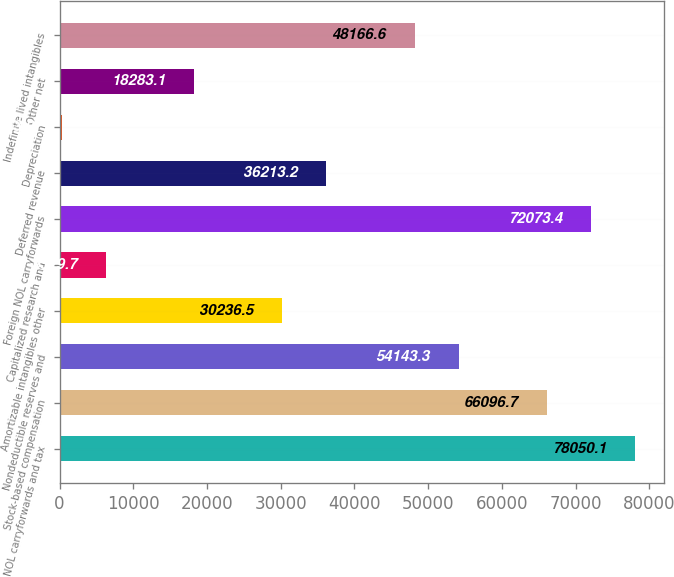<chart> <loc_0><loc_0><loc_500><loc_500><bar_chart><fcel>NOL carryforwards and tax<fcel>Stock-based compensation<fcel>Nondeductible reserves and<fcel>Amortizable intangibles other<fcel>Capitalized research and<fcel>Foreign NOL carryforwards<fcel>Deferred revenue<fcel>Depreciation<fcel>Other net<fcel>Indefinite lived intangibles<nl><fcel>78050.1<fcel>66096.7<fcel>54143.3<fcel>30236.5<fcel>6329.7<fcel>72073.4<fcel>36213.2<fcel>353<fcel>18283.1<fcel>48166.6<nl></chart> 